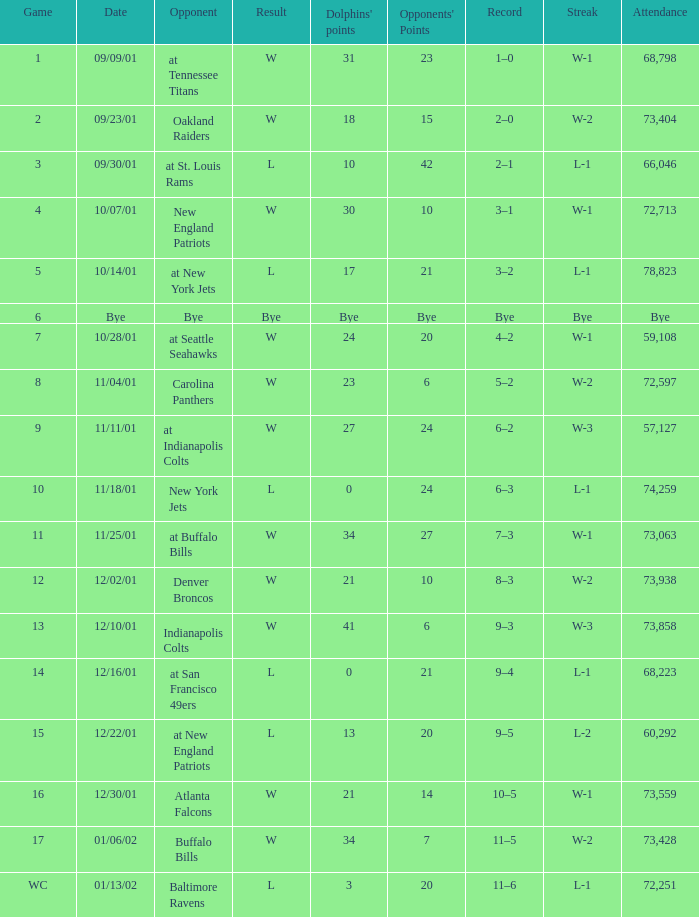What is the run for game 2? W-2. 